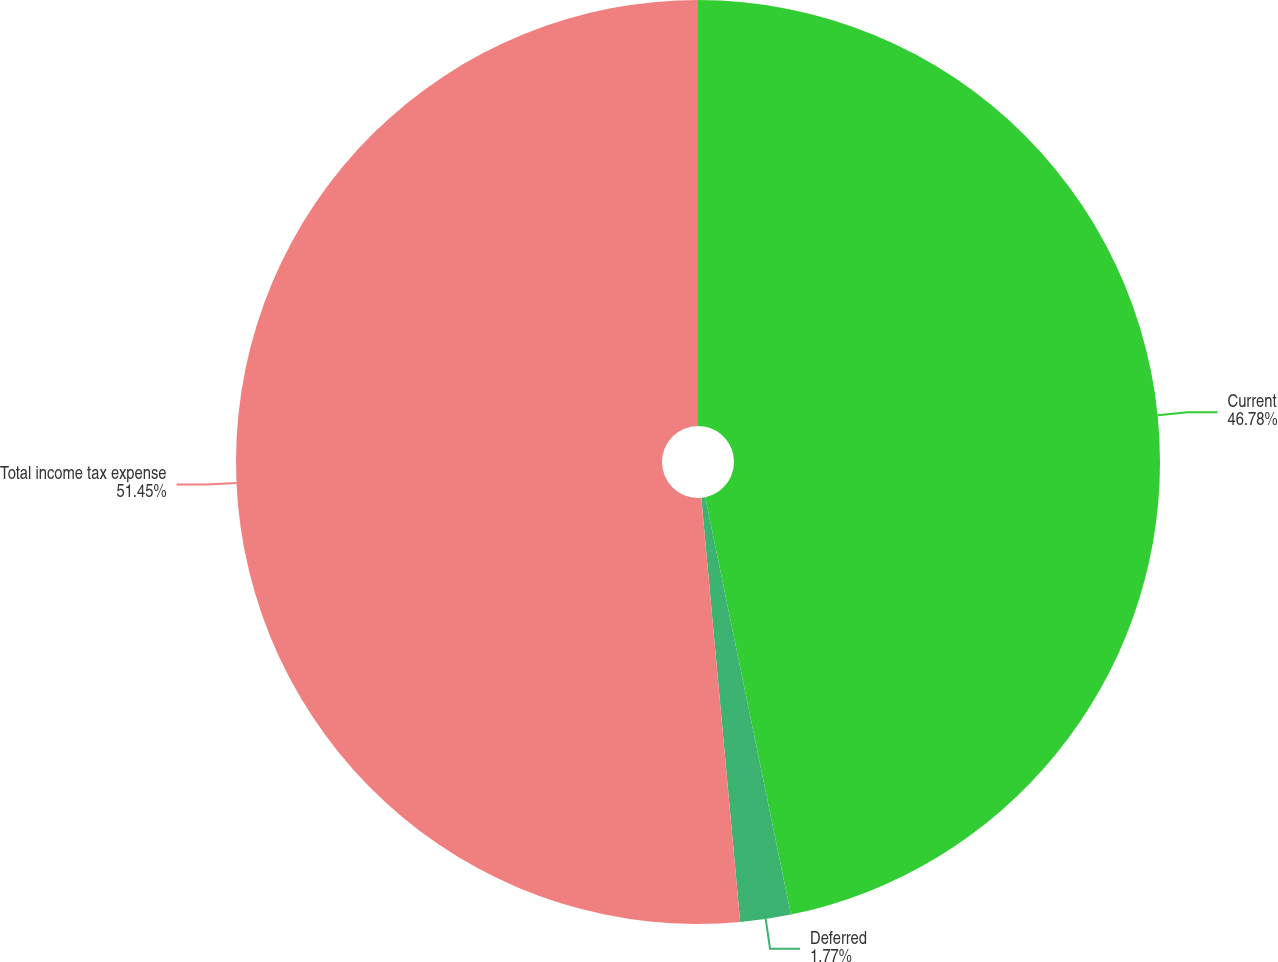Convert chart to OTSL. <chart><loc_0><loc_0><loc_500><loc_500><pie_chart><fcel>Current<fcel>Deferred<fcel>Total income tax expense<nl><fcel>46.78%<fcel>1.77%<fcel>51.46%<nl></chart> 